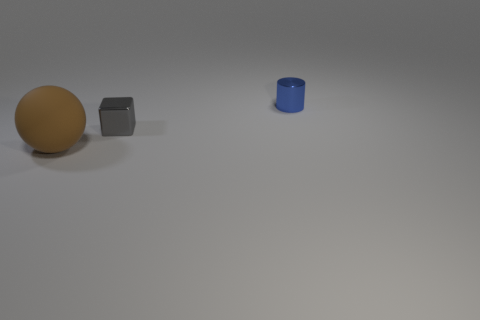Add 3 tiny cylinders. How many objects exist? 6 Subtract all blocks. How many objects are left? 2 Subtract all green spheres. Subtract all large brown matte things. How many objects are left? 2 Add 1 blue cylinders. How many blue cylinders are left? 2 Add 1 shiny objects. How many shiny objects exist? 3 Subtract 0 red cylinders. How many objects are left? 3 